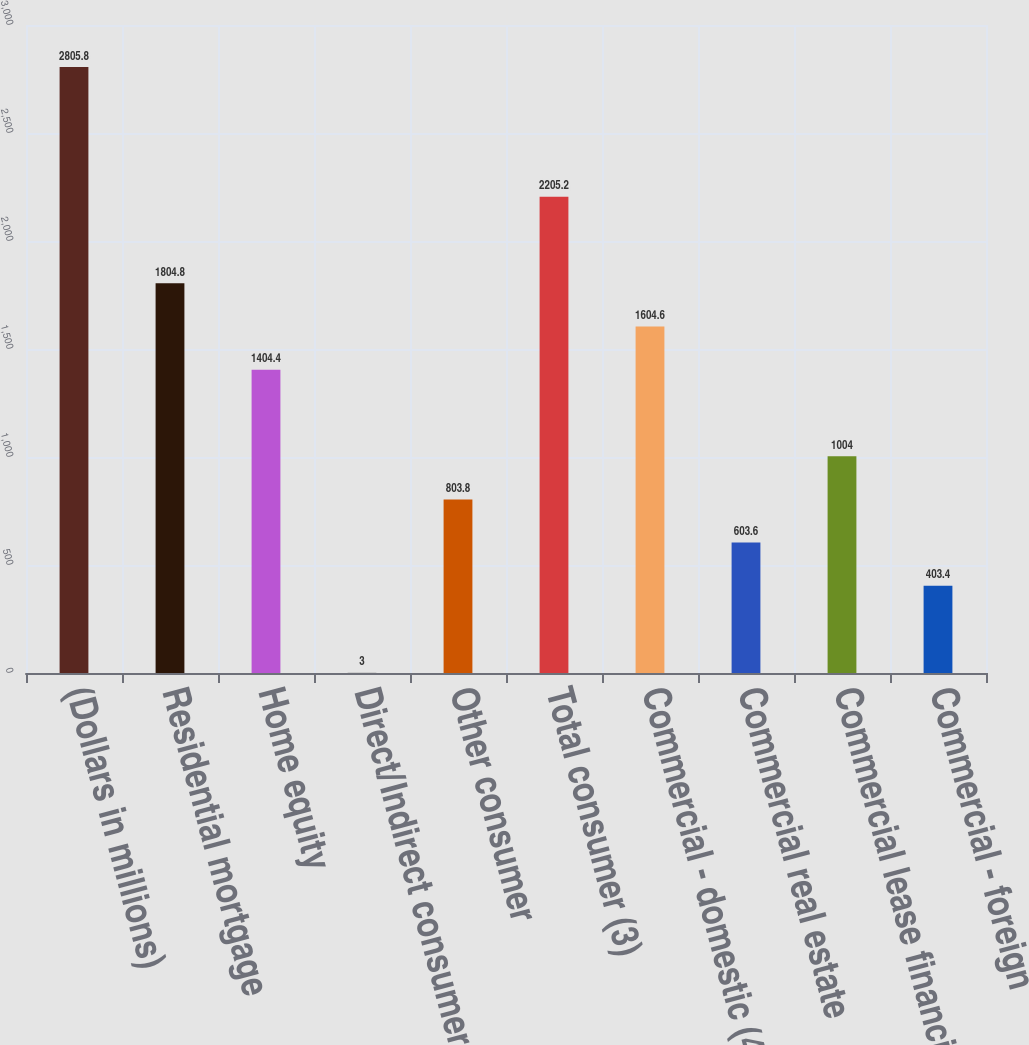<chart> <loc_0><loc_0><loc_500><loc_500><bar_chart><fcel>(Dollars in millions)<fcel>Residential mortgage<fcel>Home equity<fcel>Direct/Indirect consumer<fcel>Other consumer<fcel>Total consumer (3)<fcel>Commercial - domestic (4)<fcel>Commercial real estate<fcel>Commercial lease financing<fcel>Commercial - foreign<nl><fcel>2805.8<fcel>1804.8<fcel>1404.4<fcel>3<fcel>803.8<fcel>2205.2<fcel>1604.6<fcel>603.6<fcel>1004<fcel>403.4<nl></chart> 